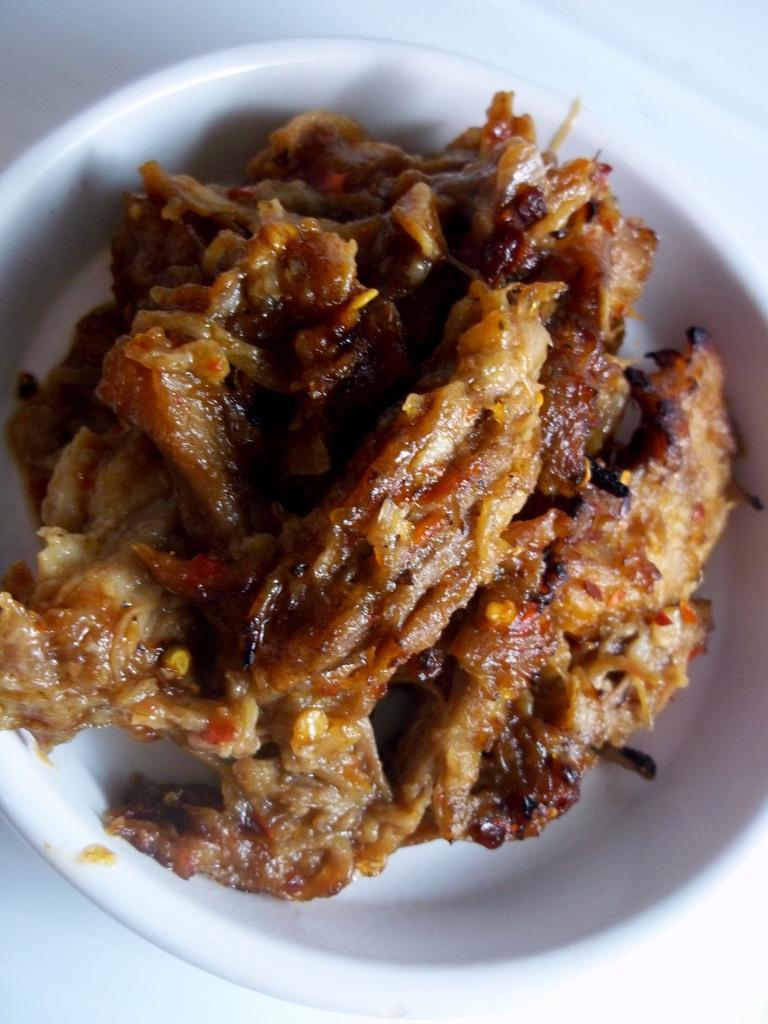What color is the plate in the image? The plate in the image is white. What type of food is on the plate? There is brown color food on the plate. What type of ball is visible in the image? There is no ball present in the image. What is the source of light in the image? The source of light is not visible in the image, but the presence of brown color food on the white plate suggests that there is sufficient lighting for the image to be taken. 